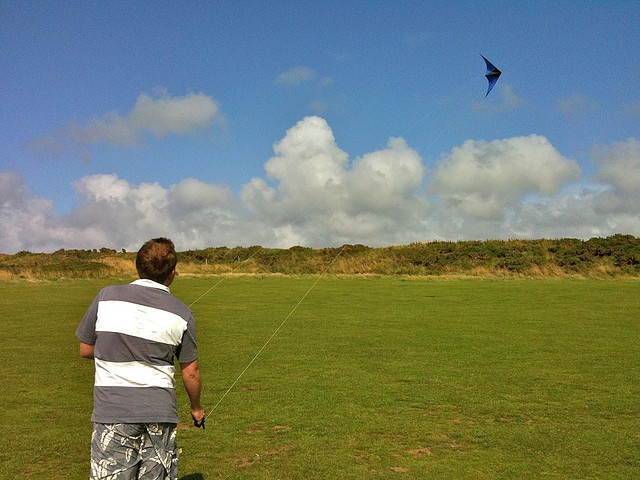Describe the objects in this image and their specific colors. I can see people in gray, white, and black tones and kite in gray, black, navy, and blue tones in this image. 